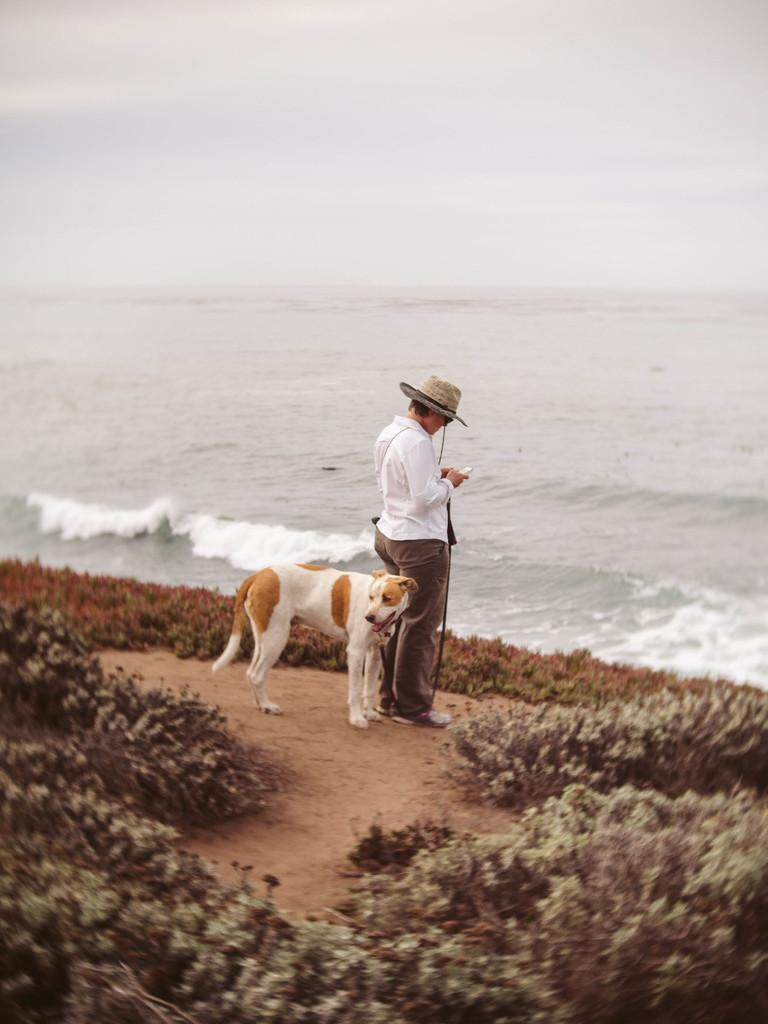Who is present in the image? There is a man in the image. What is the man standing in front of? The man is standing in front of a sea. Is there any other living being present in the image? Yes, there is a dog standing beside the man. What is the man wearing on his upper body? The man is wearing a white shirt. What type of headwear is the man wearing? The man is wearing a hat. What type of vegetation can be seen on the ground in the image? There are shrubs on the ground in the image. What type of treatment is the man receiving for his leaf-related injury in the image? There is no indication of any injury or treatment in the image. Additionally, there is no mention of a leaf in the provided facts. 